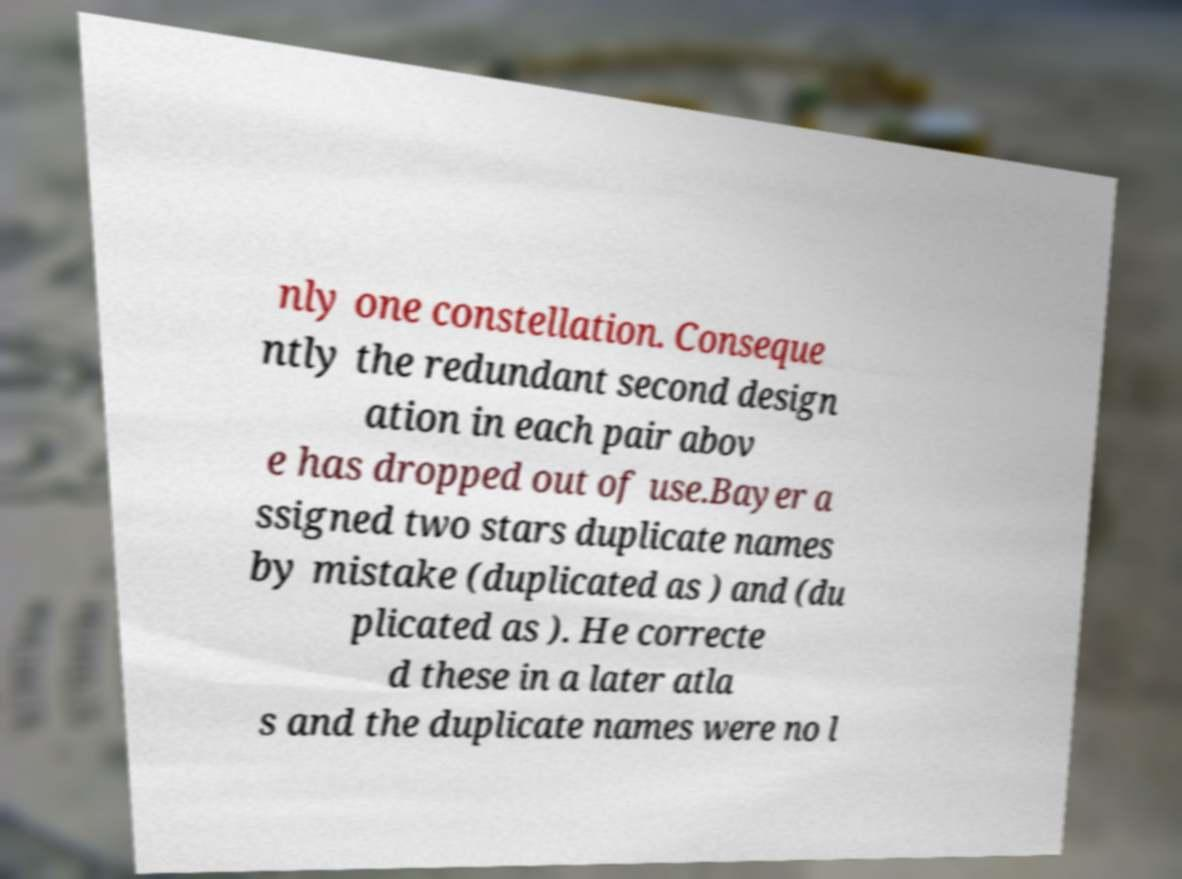For documentation purposes, I need the text within this image transcribed. Could you provide that? nly one constellation. Conseque ntly the redundant second design ation in each pair abov e has dropped out of use.Bayer a ssigned two stars duplicate names by mistake (duplicated as ) and (du plicated as ). He correcte d these in a later atla s and the duplicate names were no l 